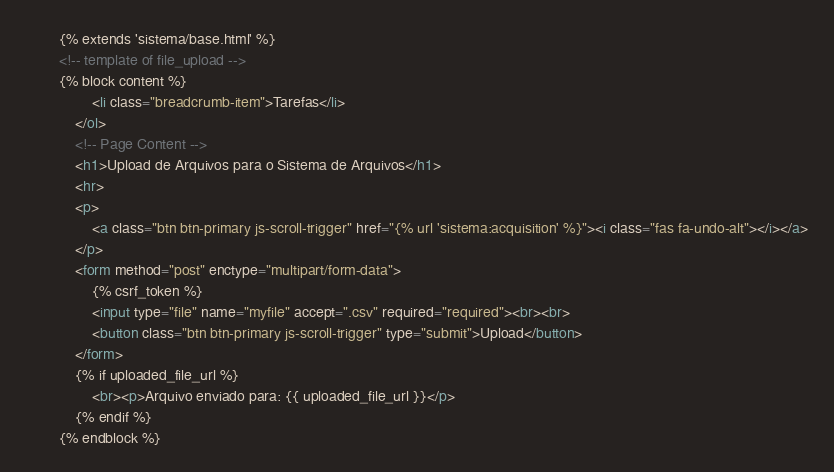Convert code to text. <code><loc_0><loc_0><loc_500><loc_500><_HTML_>        {% extends 'sistema/base.html' %}
        <!-- template of file_upload -->
        {% block content %}
                <li class="breadcrumb-item">Tarefas</li>
            </ol>
            <!-- Page Content -->
            <h1>Upload de Arquivos para o Sistema de Arquivos</h1>
            <hr>
            <p>
                <a class="btn btn-primary js-scroll-trigger" href="{% url 'sistema:acquisition' %}"><i class="fas fa-undo-alt"></i></a>
            </p>
            <form method="post" enctype="multipart/form-data">
                {% csrf_token %}
                <input type="file" name="myfile" accept=".csv" required="required"><br><br>
                <button class="btn btn-primary js-scroll-trigger" type="submit">Upload</button>
            </form>
            {% if uploaded_file_url %}
                <br><p>Arquivo enviado para: {{ uploaded_file_url }}</p>
            {% endif %}
        {% endblock %}</code> 